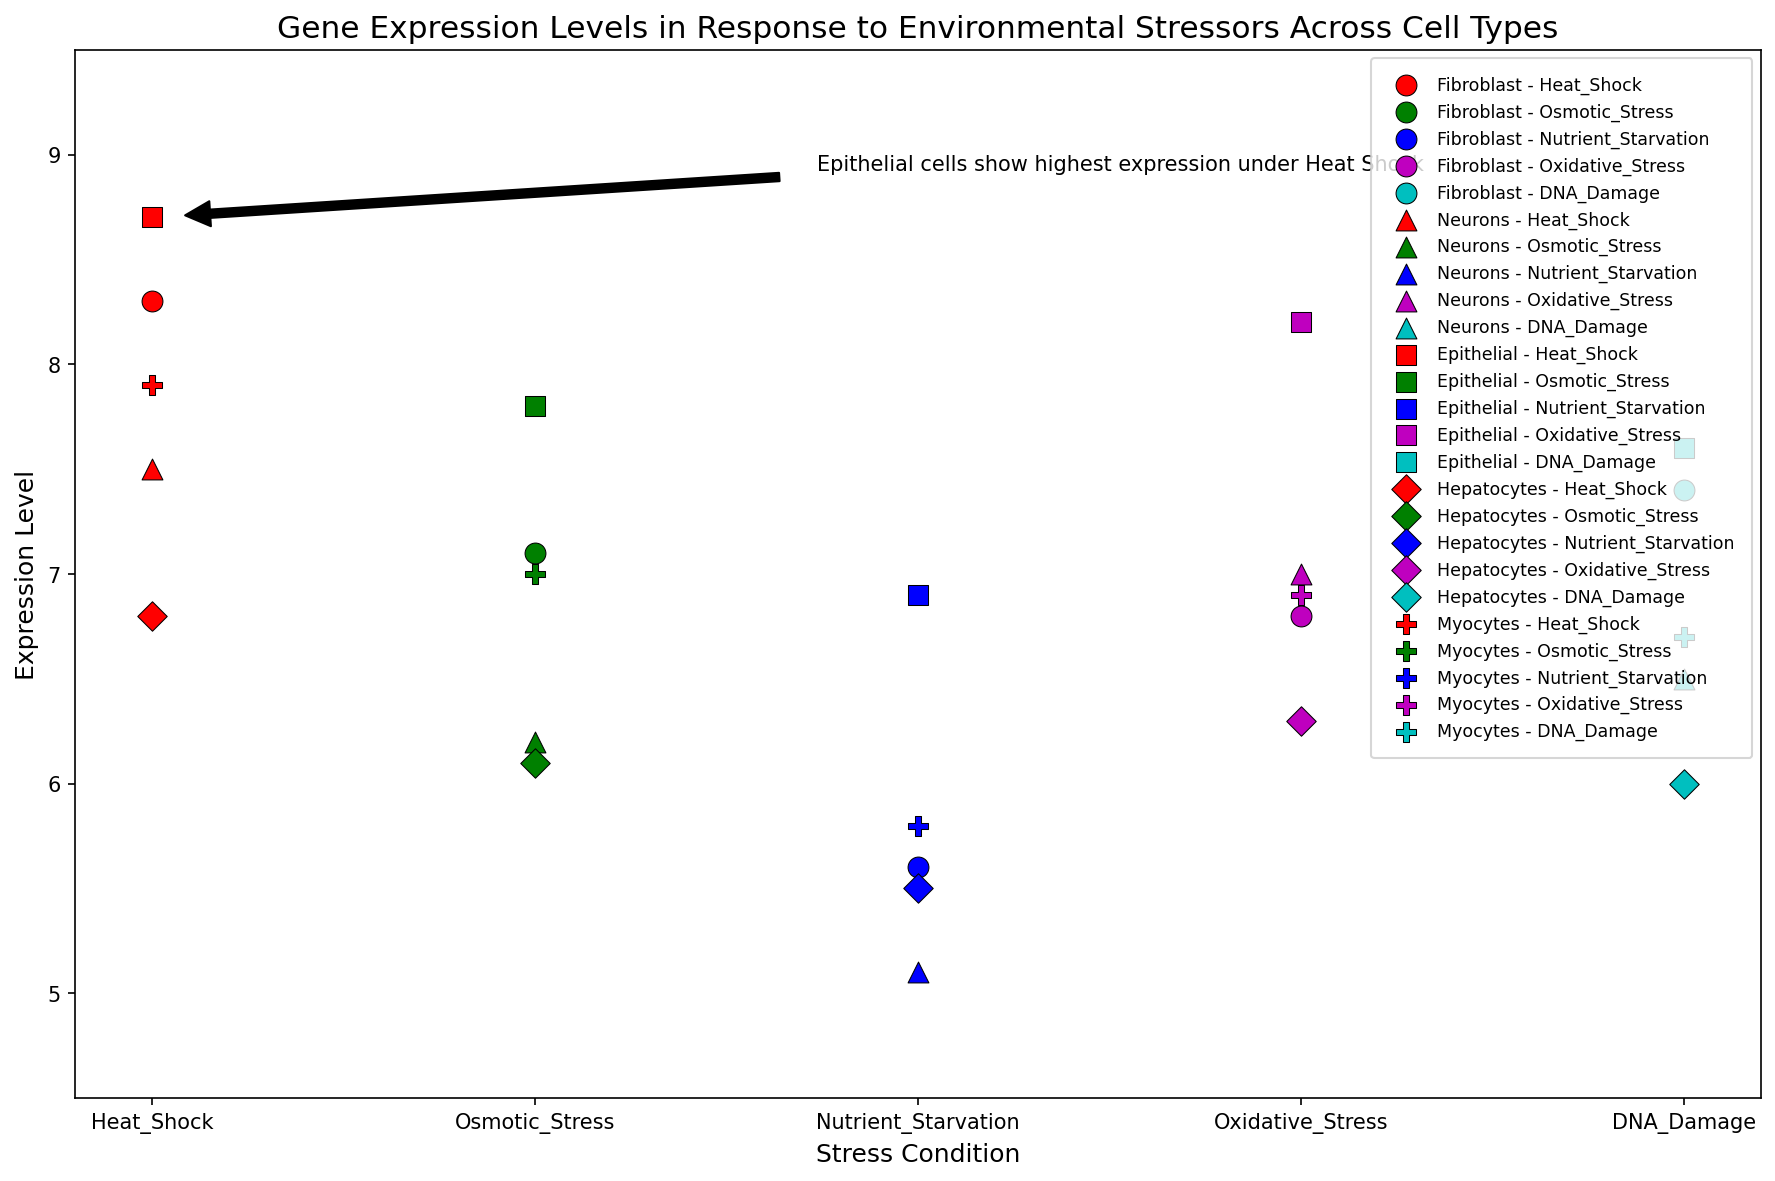Which cell type has the highest gene expression level under oxidative stress? To answer this question, look for the visual markers representing each cell type under oxidative stress conditions. The Epithelial cell (square marker) has an expression level of 8.2, which is the highest.
Answer: Epithelial What is the difference in expression levels between Epithelial and Neurons under nutrient starvation? Locate the expression levels for Epithelial and Neurons under nutrient starvation (blue in the legend). Epithelial has an expression level of 6.9 and Neurons have 5.1. The difference is 6.9 - 5.1.
Answer: 1.8 Are the expression levels under DNA damage conditions higher in Fibroblasts or Hepatocytes? Look for the markers representing Fibroblast and Hepatocytes under DNA Damage (cyan). Fibroblast has an expression level of 7.4, and Hepatocytes have 6.0. Since 7.4 is greater, Fibroblasts have higher expression levels.
Answer: Fibroblasts Which stress condition results in the highest expression level for Myocytes? Find the stress condition markers for Myocytes and compare their values. The highest value for Myocytes is 7.9, which occurs under Heat Shock (red).
Answer: Heat Shock Which two cell types have the closest expression levels under osmotic stress? Osmotic stress markers are green. Compare the expression levels: Fibroblast (7.1), Neurons (6.2), Epithelial (7.8), Hepatocytes (6.1), Myocytes (7.0). Fibroblast and Myocytes are closest, with a difference of 0.1.
Answer: Fibroblast and Myocytes Is the expression level higher in Neurons under heat shock or in Myocytes under oxidative stress? Locate the expression levels for Neurons under Heat Shock (7.5) and Myocytes under Oxidative Stress (6.9) on the plot. 7.5 is higher than 6.9.
Answer: Neurons under Heat Shock What is the average expression level for Fibroblasts across all stress conditions? Sum the expression levels for Fibroblast: 8.3 + 7.1 + 5.6 + 6.8 + 7.4 = 35.2. Divide by the number of conditions (5): 35.2 / 5.
Answer: 7.04 Which stress condition results in the lowest expression level in Neurons? Check Neurons for each stress condition and find the lowest value. Neurons under Nutrient Starvation have an expression level of 5.1, which is the lowest.
Answer: Nutrient Starvation How many cell types show an expression level above 7.0 under oxidative stress? Look at the expression levels under Oxidative Stress (magenta). Fibroblast (6.8), Neurons (7.0), Epithelial (8.2), Hepatocytes (6.3), Myocytes (6.9). Only Epithelial and Neurons are above 7.0.
Answer: 2 Under which stress condition do Epithelial and Myocytes have the same expression level? Compare the expression levels of Epithelial and Myocytes across all conditions. Both have the same level under Osmotic Stress (7.0 for Myocytes and 7.8 for Epithelial). They do not have matching levels under any condition exactly.
Answer: None 